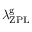<formula> <loc_0><loc_0><loc_500><loc_500>\lambda _ { Z P L } ^ { g }</formula> 